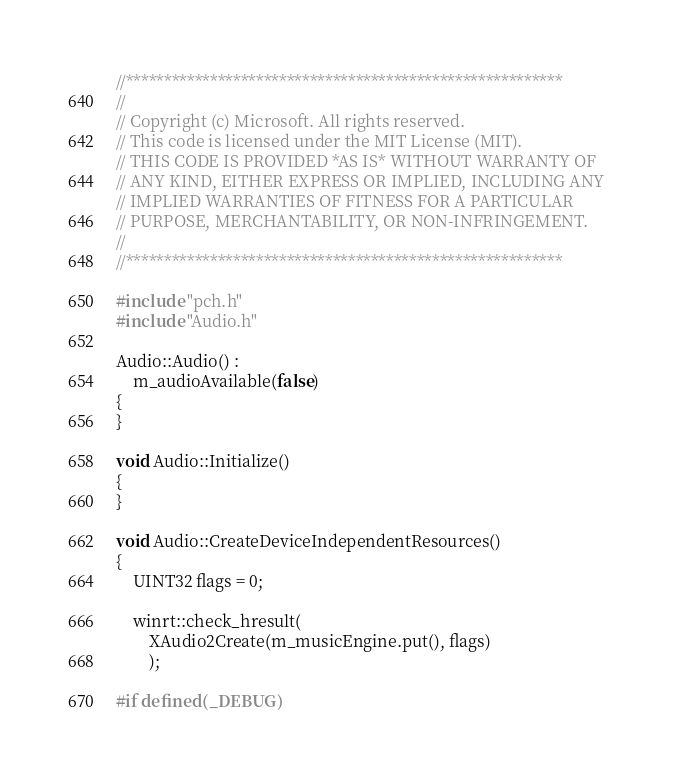Convert code to text. <code><loc_0><loc_0><loc_500><loc_500><_C++_>//********************************************************* 
// 
// Copyright (c) Microsoft. All rights reserved. 
// This code is licensed under the MIT License (MIT). 
// THIS CODE IS PROVIDED *AS IS* WITHOUT WARRANTY OF 
// ANY KIND, EITHER EXPRESS OR IMPLIED, INCLUDING ANY 
// IMPLIED WARRANTIES OF FITNESS FOR A PARTICULAR 
// PURPOSE, MERCHANTABILITY, OR NON-INFRINGEMENT. 
// 
//*********************************************************

#include "pch.h"
#include "Audio.h"

Audio::Audio() :
    m_audioAvailable(false)
{
}

void Audio::Initialize()
{
}

void Audio::CreateDeviceIndependentResources()
{
    UINT32 flags = 0;

    winrt::check_hresult(
        XAudio2Create(m_musicEngine.put(), flags)
        );

#if defined(_DEBUG)</code> 